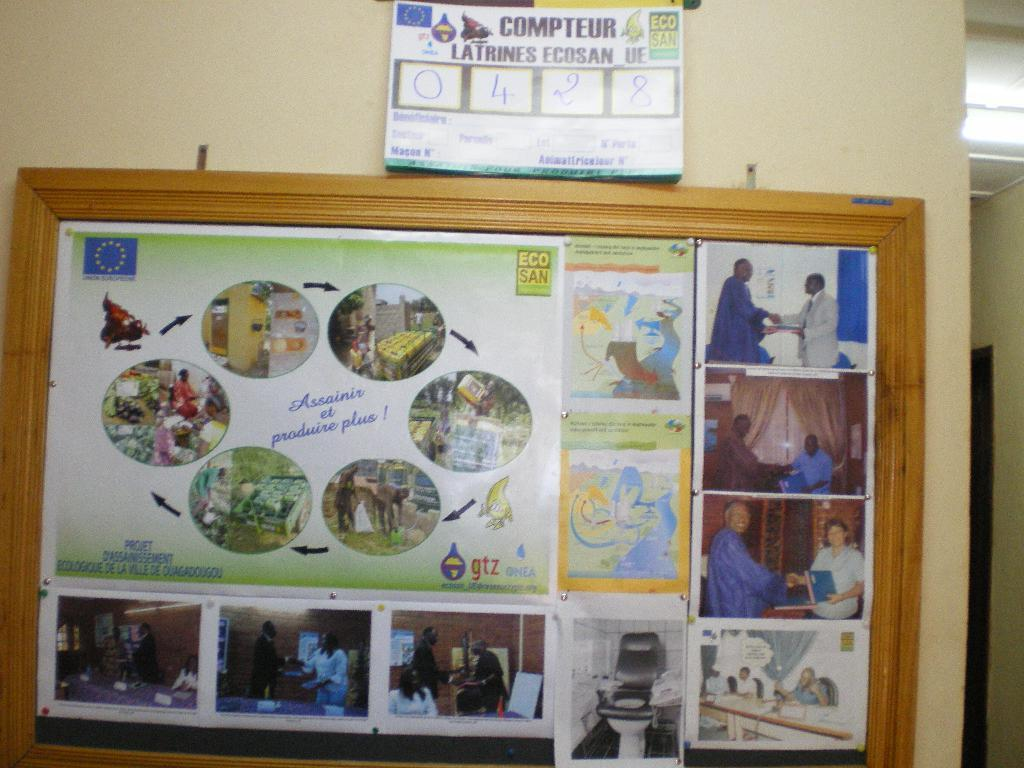<image>
Relay a brief, clear account of the picture shown. A collection of pictures and a sign above them that states COMPTEUR. 